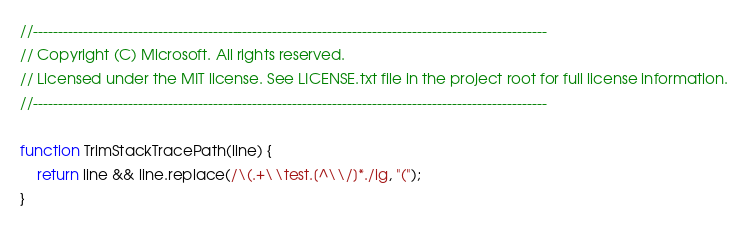Convert code to text. <code><loc_0><loc_0><loc_500><loc_500><_JavaScript_>//-------------------------------------------------------------------------------------------------------
// Copyright (C) Microsoft. All rights reserved.
// Licensed under the MIT license. See LICENSE.txt file in the project root for full license information.
//-------------------------------------------------------------------------------------------------------

function TrimStackTracePath(line) {
    return line && line.replace(/\(.+\\test.[^\\/]*./ig, "(");
}
</code> 